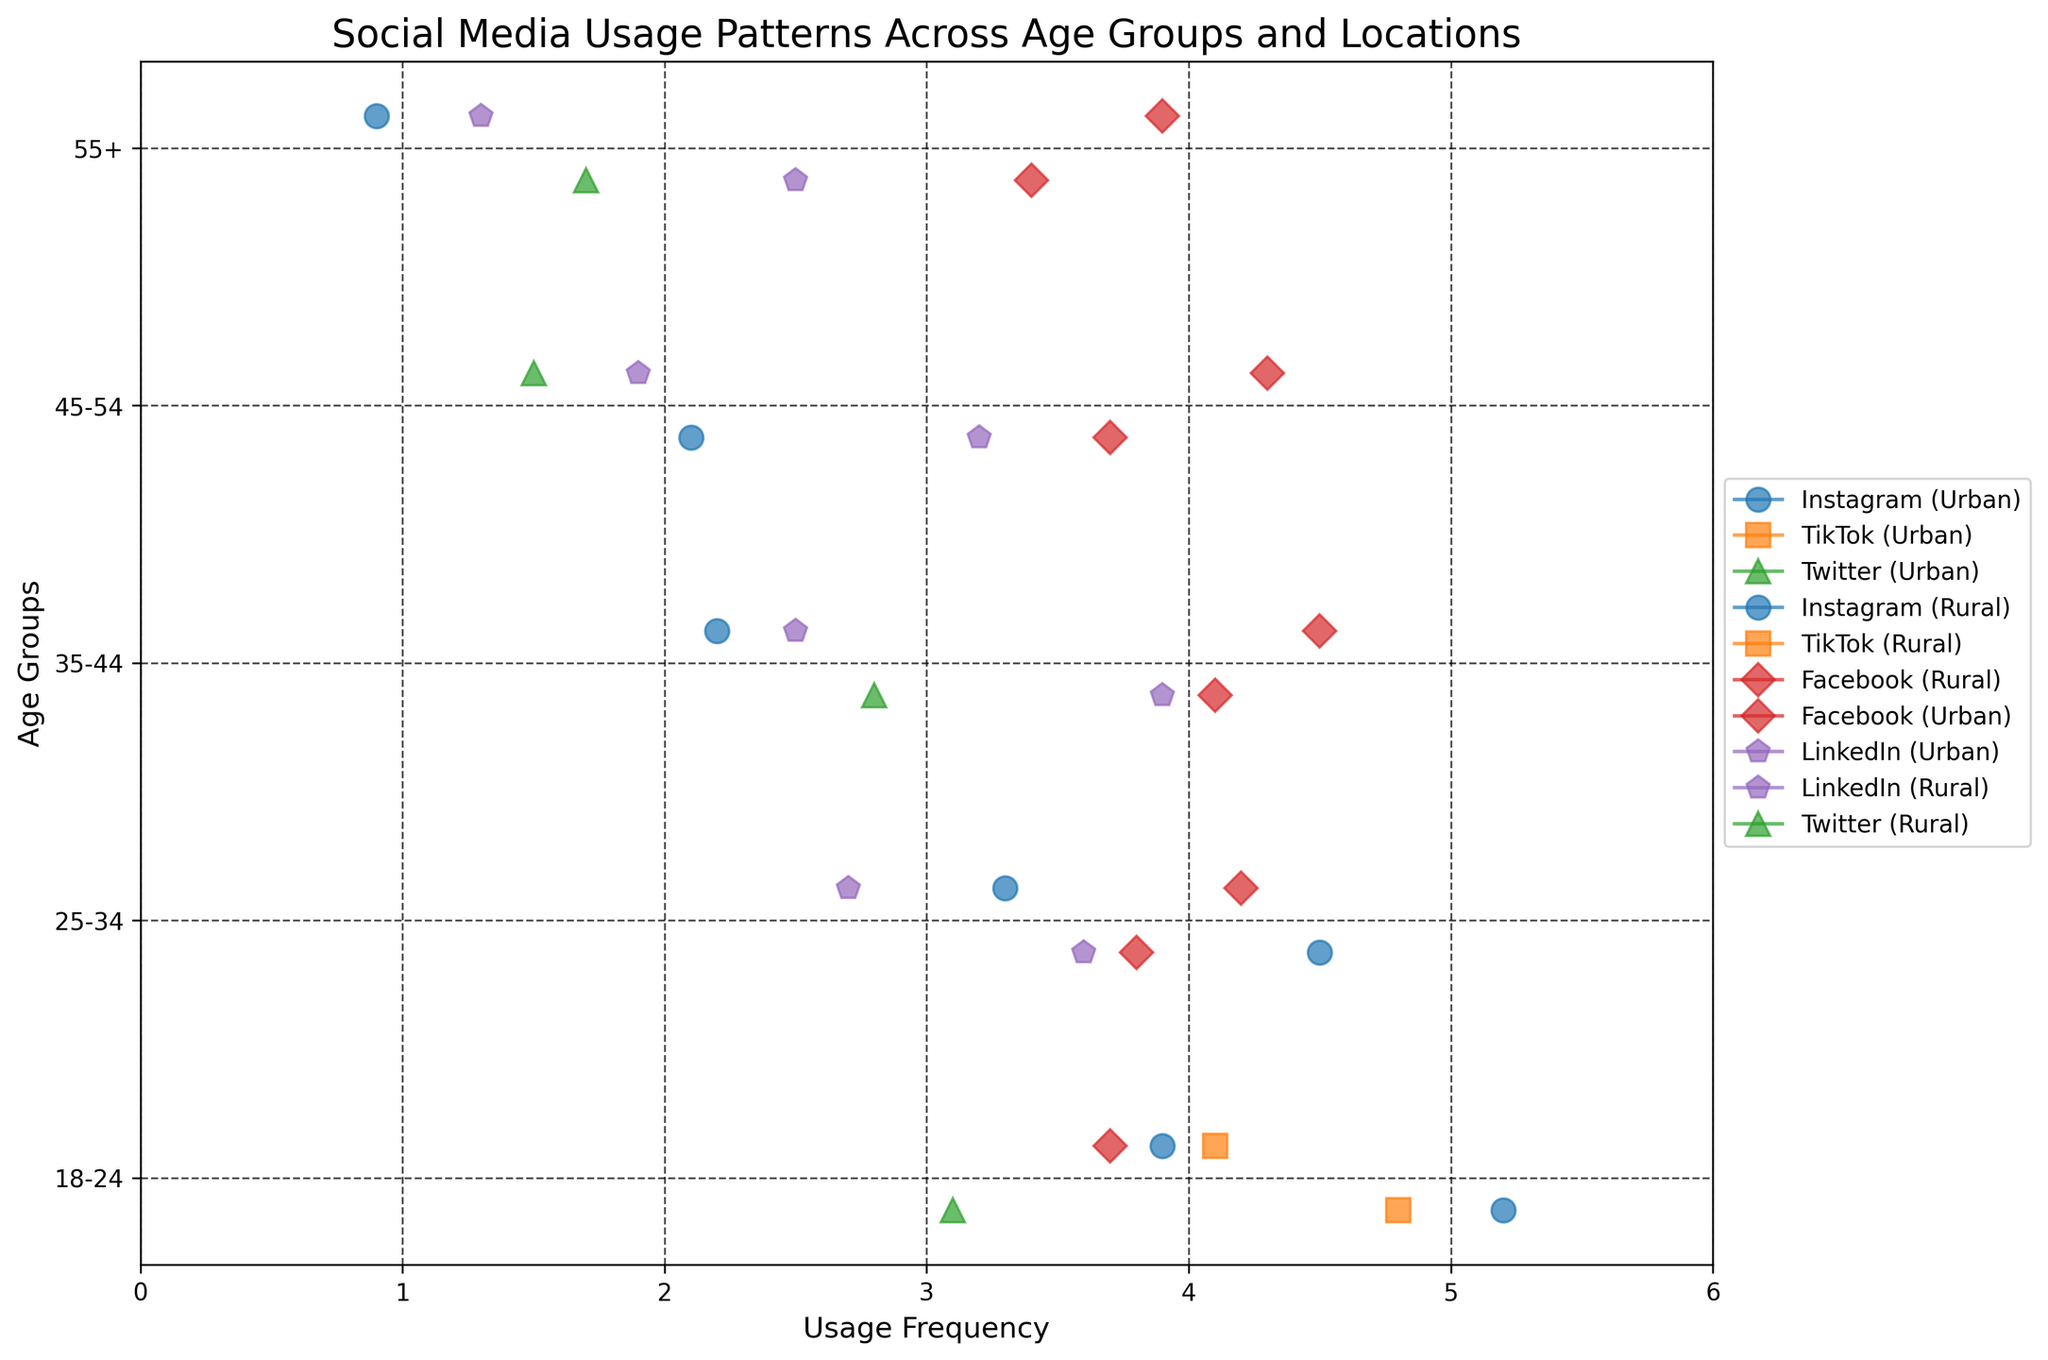What is the title of the plot? The title of the plot is generally displayed at the top of the figure, and it summarizes the main topic being visualized. In this case, it states, "Social Media Usage Patterns Across Age Groups and Locations".
Answer: Social Media Usage Patterns Across Age Groups and Locations What does the x-axis represent in the plot? The x-axis of the plot is labeled to indicate what is being measured along it. Here, it is labeled "Usage Frequency", representing how frequently different age groups use various social media platforms.
Answer: Usage Frequency Which age group has the highest usage frequency for Instagram in urban areas? To find this, look for the age group with the highest data point for Instagram in Urban areas marked by the specific color and marker used in the plot. The highest point for Instagram in urban areas is found for the 18-24 age group.
Answer: 18-24 What is the difference in Facebook usage frequency between rural and urban areas in the 35-44 age group? To find this, locate the Facebook usage frequency data points for both rural and urban areas in the 35-44 age group and calculate their difference. The urban frequency is 4.1, and the rural frequency is 4.5. The difference is 4.5 - 4.1.
Answer: 0.4 Which platform has the lowest usage frequency in the 55+ age group in rural areas? Locate all the platforms for the 55+ age group in rural areas and find the one with the lowest usage frequency. The plot should show that Instagram has the lowest frequency point at 0.9.
Answer: Instagram How does LinkedIn usage in rural areas compare between the 25-34 and 35-44 age groups? Identify the LinkedIn usage frequency points for rural areas in both the 25-34 and 35-44 age groups. Compare their values; 25-34 age group has a frequency of 2.7, while the 35-44 age group has a frequency of 2.5.
Answer: 25-34 age group has higher usage What is the average usage frequency of Twitter in urban areas across all age groups? Find the Twitter usage frequency points in urban areas for different age groups and calculate their average. Twitter usage for 18-24 is 3.1, 35-44 is 2.8, and 55+ is 1.7. The sum is 3.1 + 2.8 + 1.7 = 7.6, and the average is 7.6 / 3.
Answer: 2.53 Which age group has the most diverse usage patterns in rural areas? Look for the age group in rural areas with usage points spread across the most different platforms. The 18-24 age group shows usage of Facebook, Instagram, and TikTok, indicating a wider range of platforms used.
Answer: 18-24 What is the overall trend in Facebook usage frequency as age increases in rural areas? Identify Facebook usage frequency points in rural areas for each age group and observe the trend. The frequency points for rural areas are 3.7 (18-24), 4.2 (25-34), 4.5 (35-44), 4.3 (45-54), and 3.9 (55+). Generally, there is a peak in middle-aged groups and a slight decrease afterward.
Answer: Peaks in middle age, slight decrease in older age 